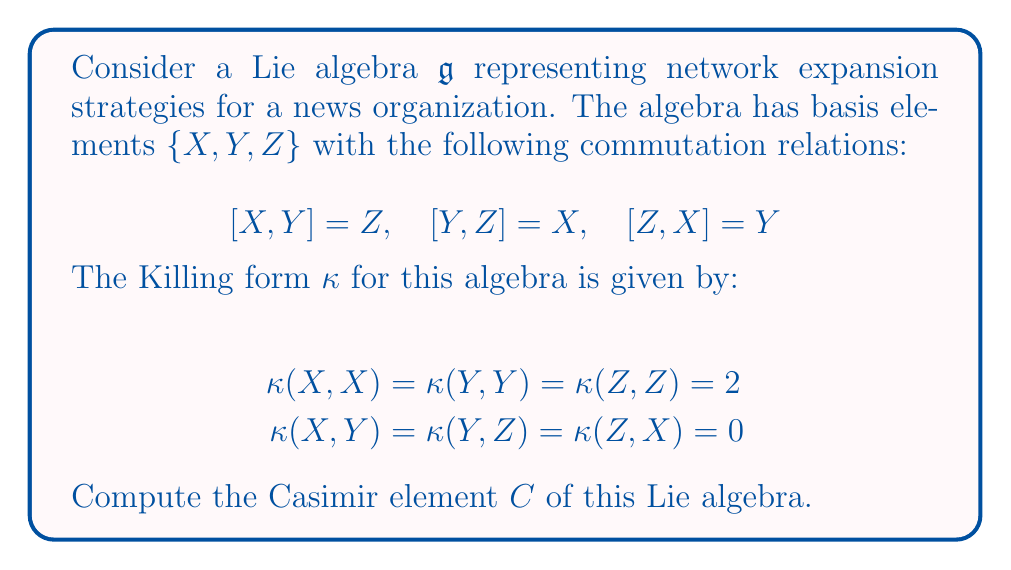Help me with this question. To compute the Casimir element of the Lie algebra, we follow these steps:

1) The Casimir element is defined as $C = \sum_{i,j} \kappa^{ij} e_i e_j$, where $\kappa^{ij}$ are the components of the inverse of the Killing form matrix, and $e_i$ are the basis elements.

2) First, we need to construct the Killing form matrix:

   $$\kappa = \begin{pmatrix}
   2 & 0 & 0 \\
   0 & 2 & 0 \\
   0 & 0 & 2
   \end{pmatrix}$$

3) The inverse of this matrix is:

   $$\kappa^{-1} = \begin{pmatrix}
   1/2 & 0 & 0 \\
   0 & 1/2 & 0 \\
   0 & 0 & 1/2
   \end{pmatrix}$$

4) Now, we can construct the Casimir element:

   $$C = \frac{1}{2}X^2 + \frac{1}{2}Y^2 + \frac{1}{2}Z^2$$

5) This can be interpreted in the context of network expansion strategies as follows:
   - $X^2$ might represent the square of the rate of geographical expansion
   - $Y^2$ might represent the square of the rate of content diversification
   - $Z^2$ might represent the square of the rate of technological advancement

   The Casimir element combines these factors with equal weights, suggesting a balanced approach to network expansion.
Answer: The Casimir element of the given Lie algebra is:

$$C = \frac{1}{2}(X^2 + Y^2 + Z^2)$$ 